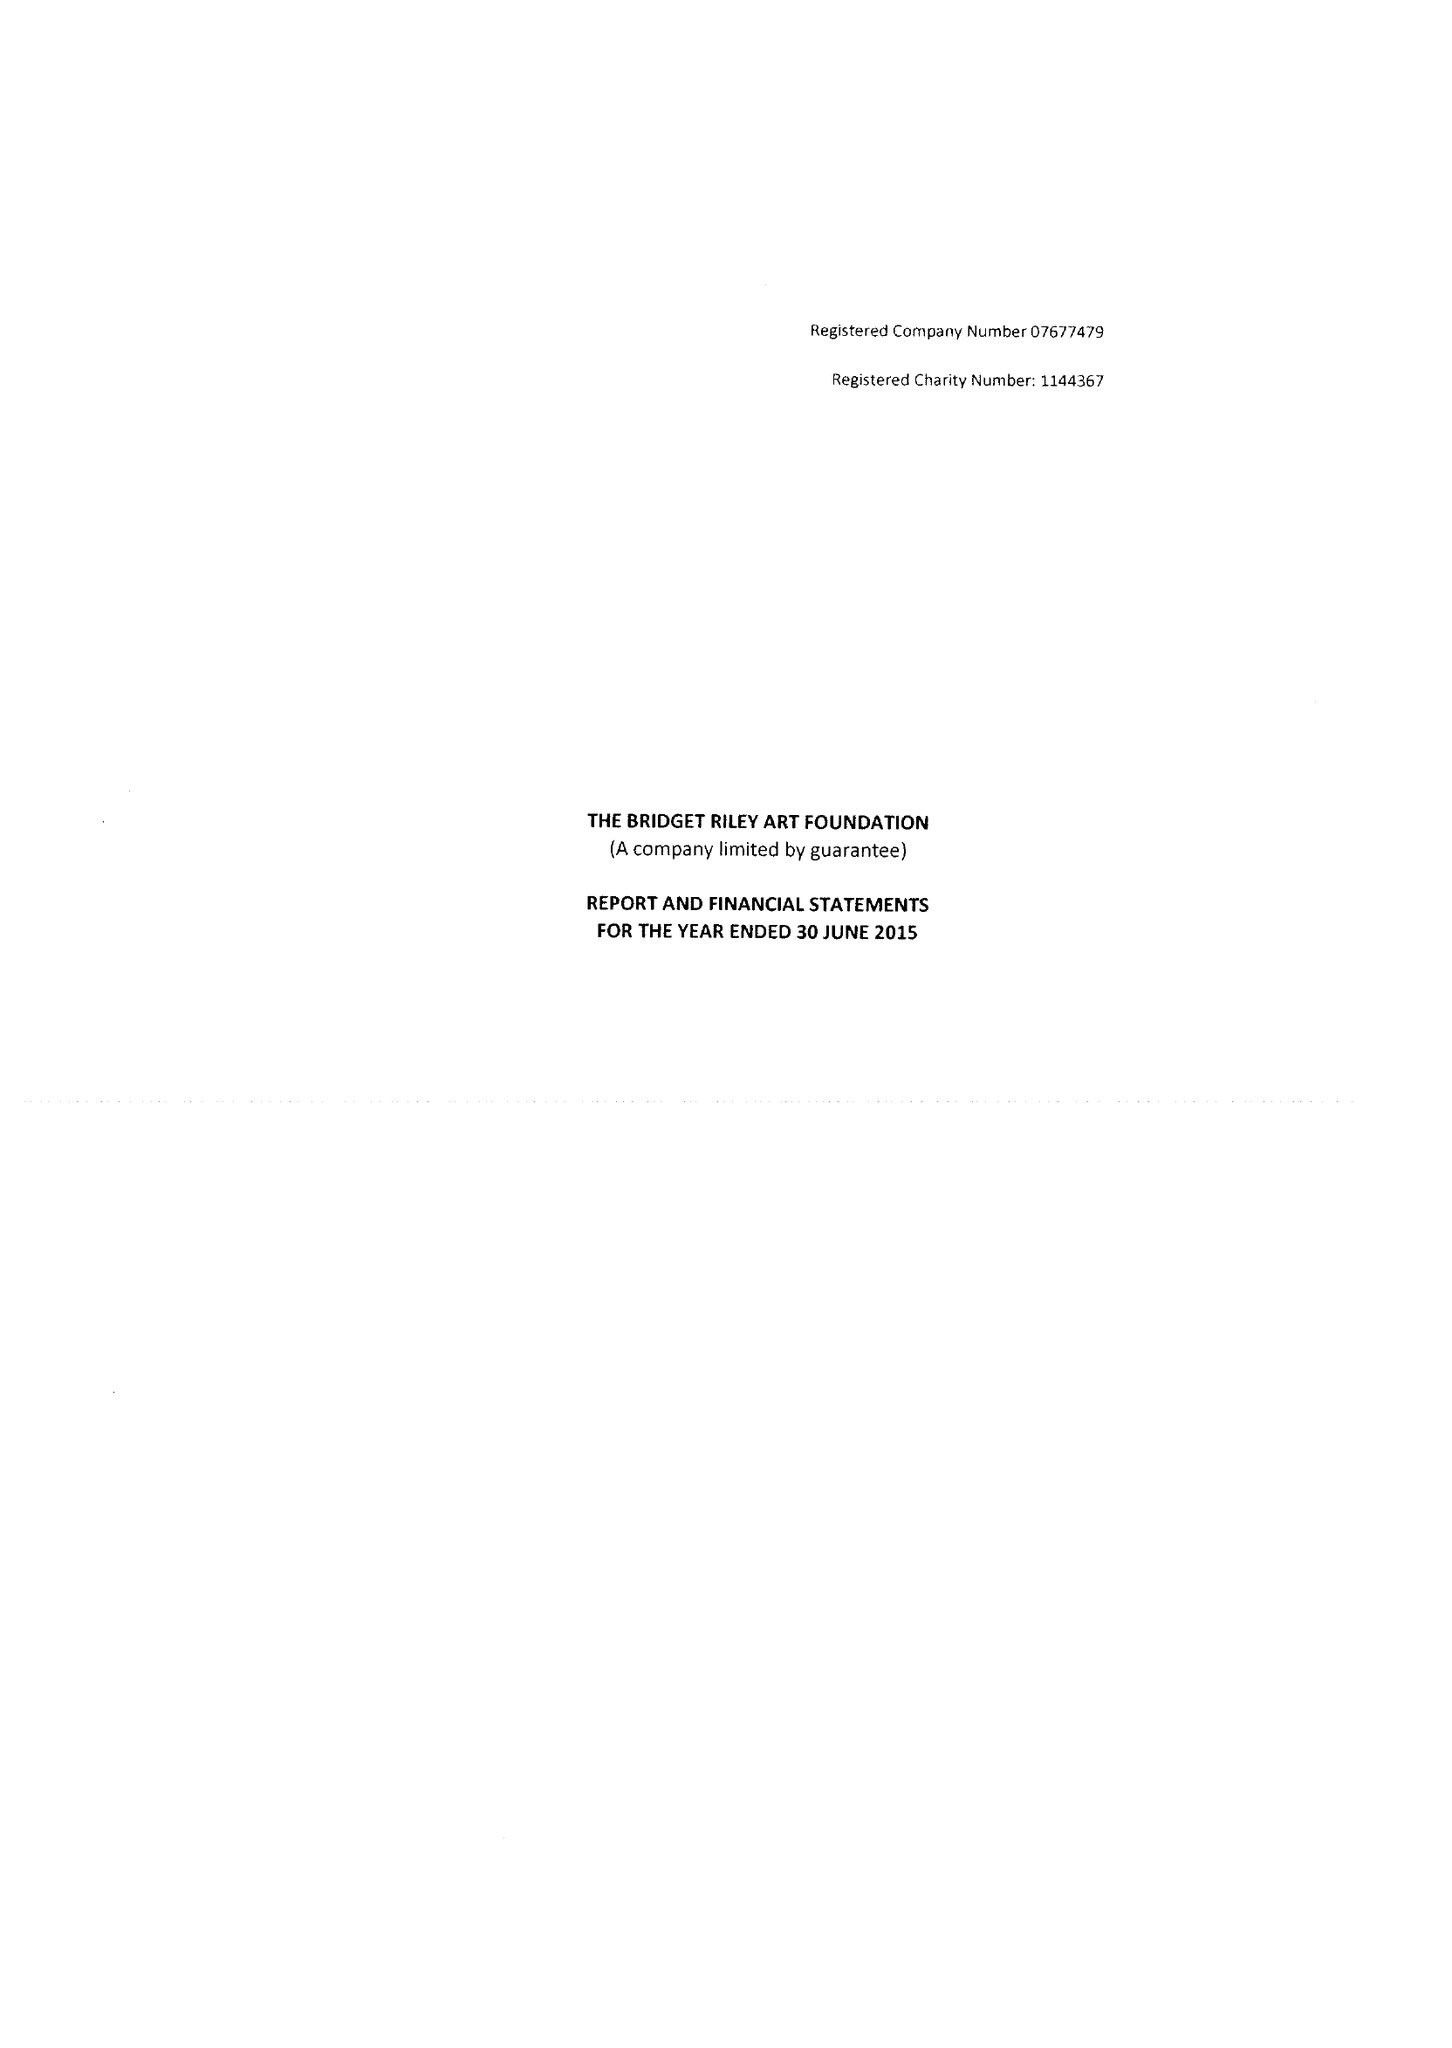What is the value for the charity_number?
Answer the question using a single word or phrase. 1144367 